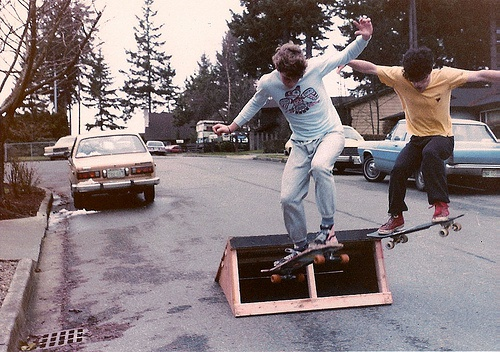Describe the objects in this image and their specific colors. I can see people in maroon, darkgray, lightgray, and gray tones, people in maroon, black, brown, gray, and tan tones, car in maroon, lightgray, black, darkgray, and gray tones, car in maroon, lightgray, black, gray, and darkgray tones, and car in maroon, lightgray, black, and gray tones in this image. 